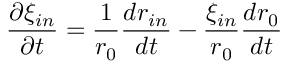<formula> <loc_0><loc_0><loc_500><loc_500>\frac { \partial \xi _ { i n } } { \partial t } = \frac { 1 } { r _ { 0 } } \frac { d r _ { i n } } { d t } - \frac { \xi _ { i n } } { r _ { 0 } } \frac { d r _ { 0 } } { d t }</formula> 